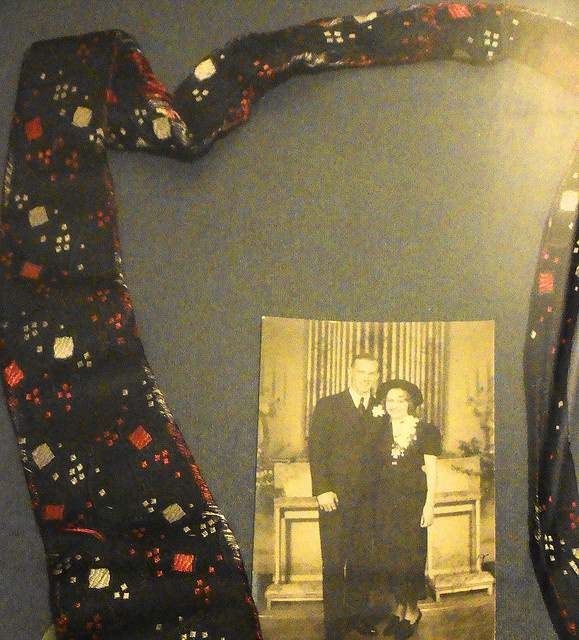Describe the objects in this image and their specific colors. I can see tie in black, olive, maroon, and gray tones, people in black, olive, and gray tones, people in black, olive, gray, and khaki tones, and tie in black, olive, tan, and gray tones in this image. 